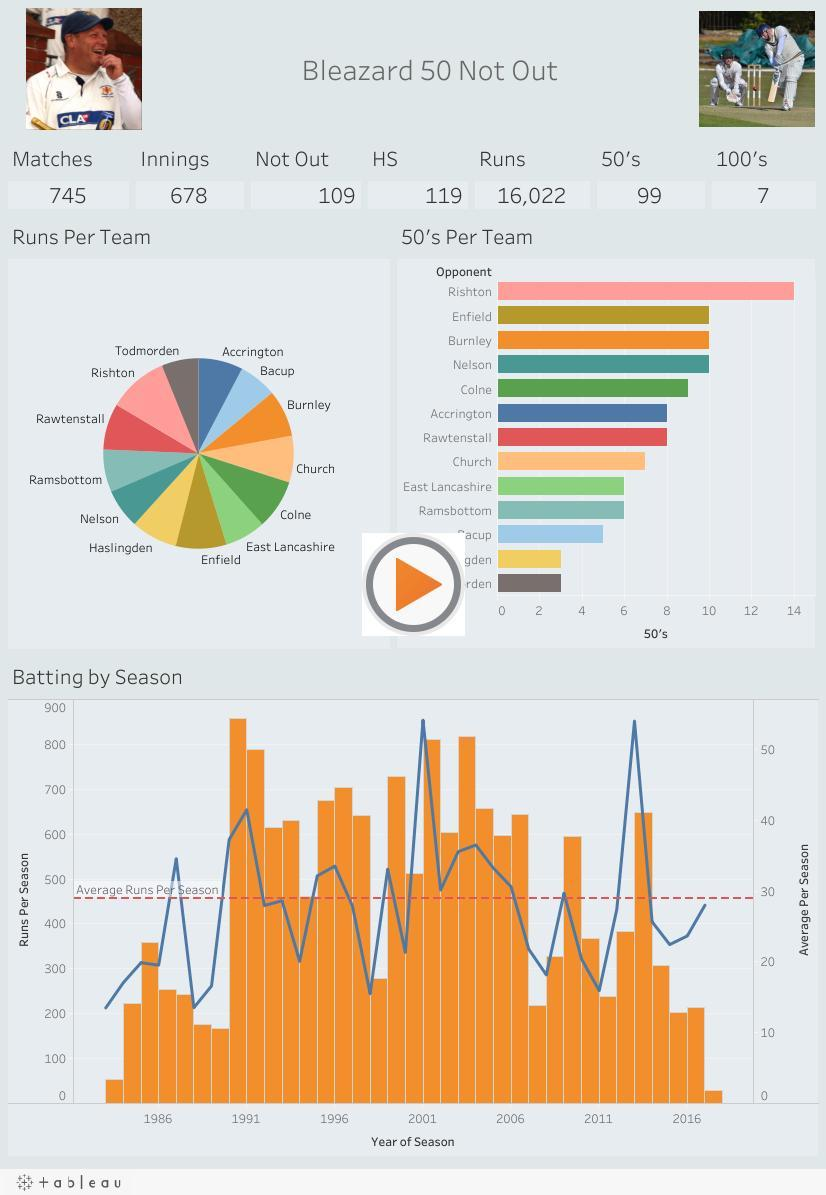What was the total runs scored by Bleazard?
Answer the question with a short phrase. 16,022 How many 50's were scored by Bleazard? 99 How many 50's were scored against Colne? 9 How many 50's were scored opposite Church team? 7 How many 100's did Bleazard score? 7 How many innings did he play? 678 How many matches were played by Bleazard? 745 